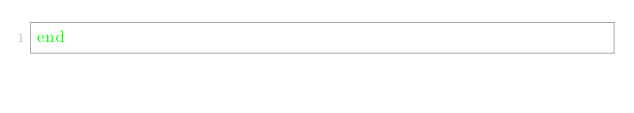<code> <loc_0><loc_0><loc_500><loc_500><_Ruby_>end
</code> 